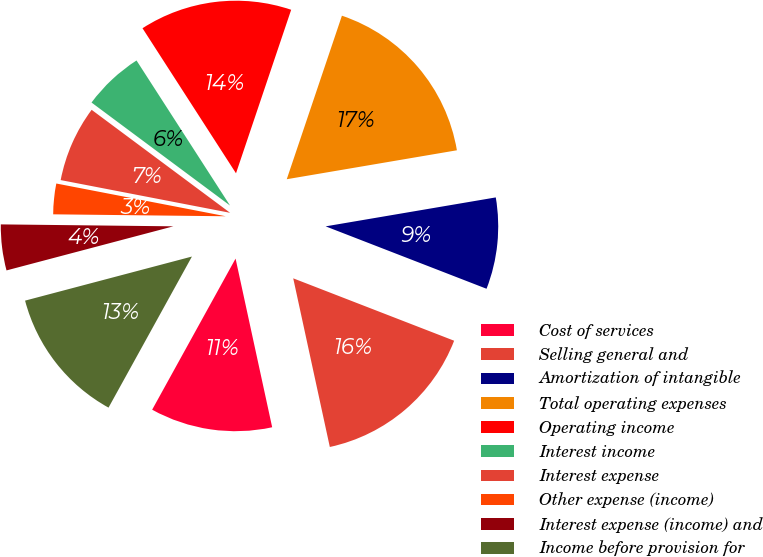Convert chart to OTSL. <chart><loc_0><loc_0><loc_500><loc_500><pie_chart><fcel>Cost of services<fcel>Selling general and<fcel>Amortization of intangible<fcel>Total operating expenses<fcel>Operating income<fcel>Interest income<fcel>Interest expense<fcel>Other expense (income)<fcel>Interest expense (income) and<fcel>Income before provision for<nl><fcel>11.43%<fcel>15.71%<fcel>8.57%<fcel>17.14%<fcel>14.29%<fcel>5.71%<fcel>7.14%<fcel>2.86%<fcel>4.29%<fcel>12.86%<nl></chart> 